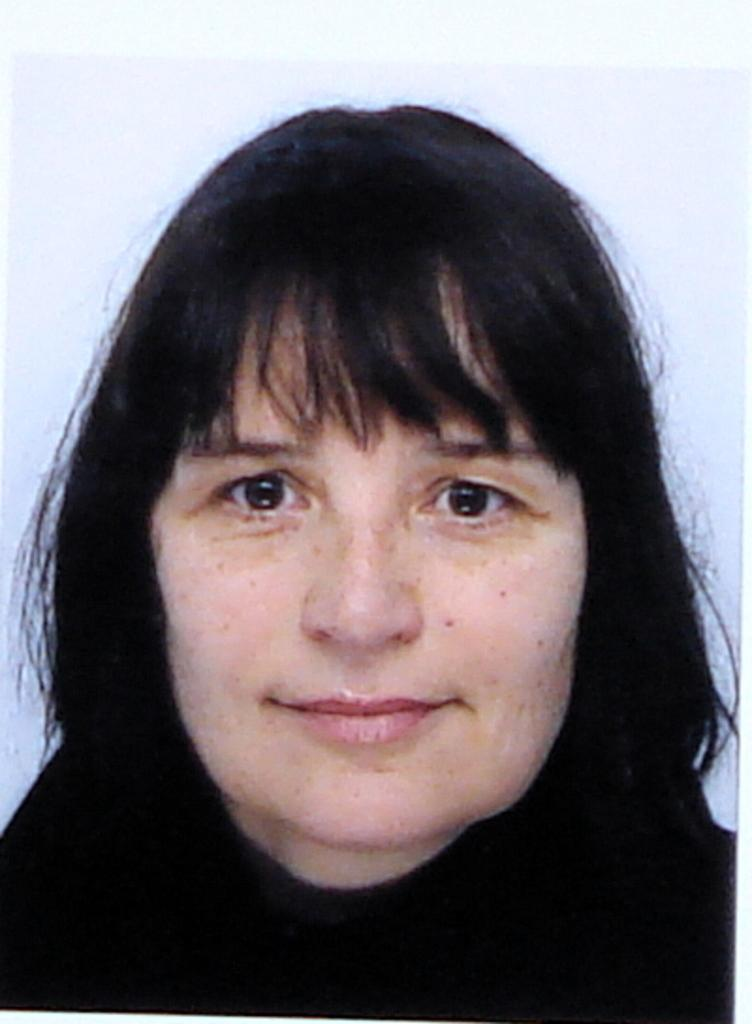What is the main subject of the picture? The main subject of the picture is a woman's face. What can be seen behind the woman in the picture? The background behind the woman is white. What expression does the woman have in the picture? The woman is smiling in the picture. How many birds are sitting on the woman's shoulder in the picture? There are no birds present in the picture. What type of drawer is visible in the picture? There is no drawer present in the picture. 